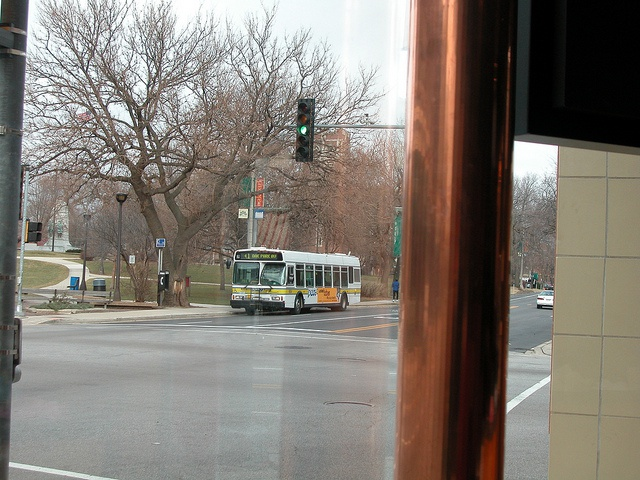Describe the objects in this image and their specific colors. I can see bus in white, gray, black, lightgray, and darkgray tones, traffic light in white, black, gray, teal, and maroon tones, car in white, darkgray, black, and gray tones, traffic light in white, black, and gray tones, and people in white, gray, black, and blue tones in this image. 